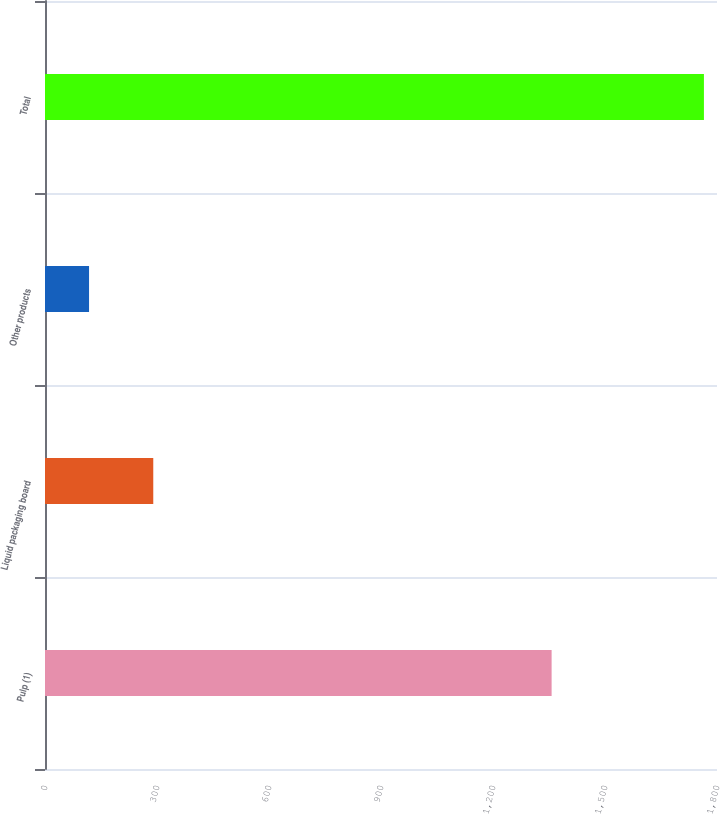Convert chart. <chart><loc_0><loc_0><loc_500><loc_500><bar_chart><fcel>Pulp (1)<fcel>Liquid packaging board<fcel>Other products<fcel>Total<nl><fcel>1357<fcel>290<fcel>118<fcel>1765<nl></chart> 